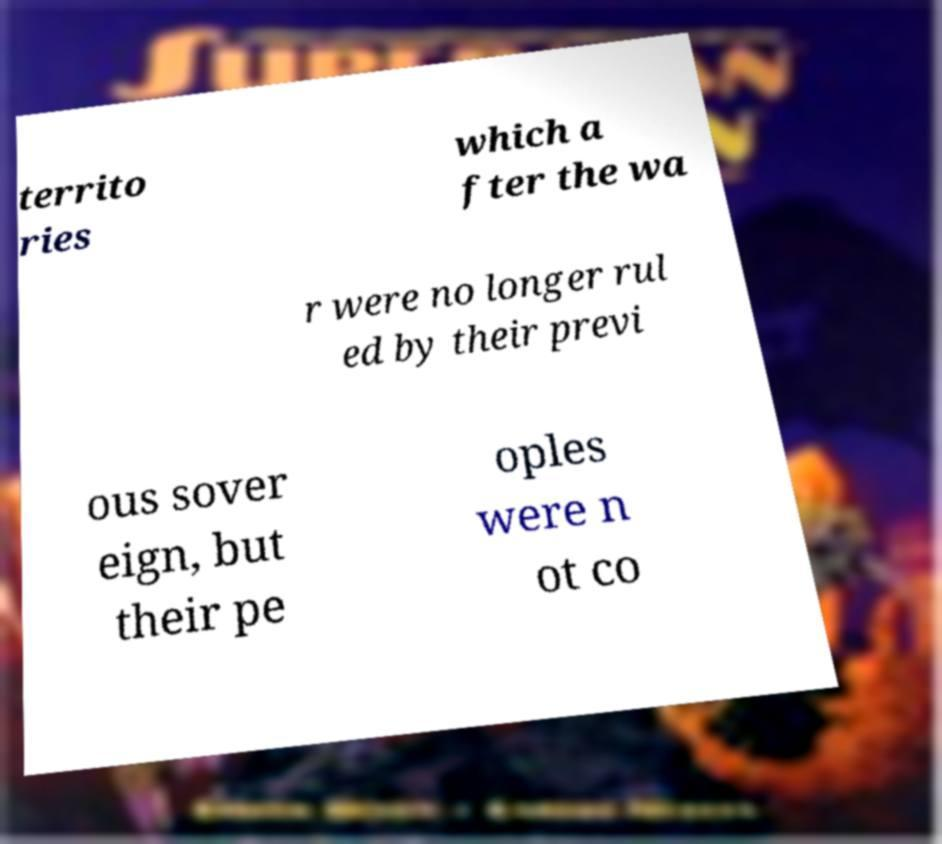Please read and relay the text visible in this image. What does it say? territo ries which a fter the wa r were no longer rul ed by their previ ous sover eign, but their pe oples were n ot co 